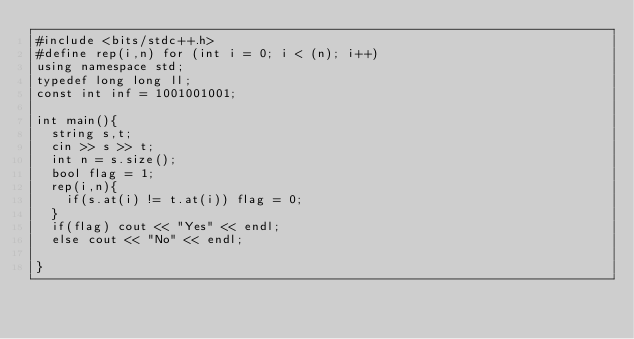<code> <loc_0><loc_0><loc_500><loc_500><_C++_>#include <bits/stdc++.h>
#define rep(i,n) for (int i = 0; i < (n); i++)
using namespace std;
typedef long long ll;
const int inf = 1001001001;

int main(){
  string s,t;
  cin >> s >> t;
  int n = s.size();
  bool flag = 1;
  rep(i,n){
    if(s.at(i) != t.at(i)) flag = 0;
  }
  if(flag) cout << "Yes" << endl;
  else cout << "No" << endl;
  
}</code> 